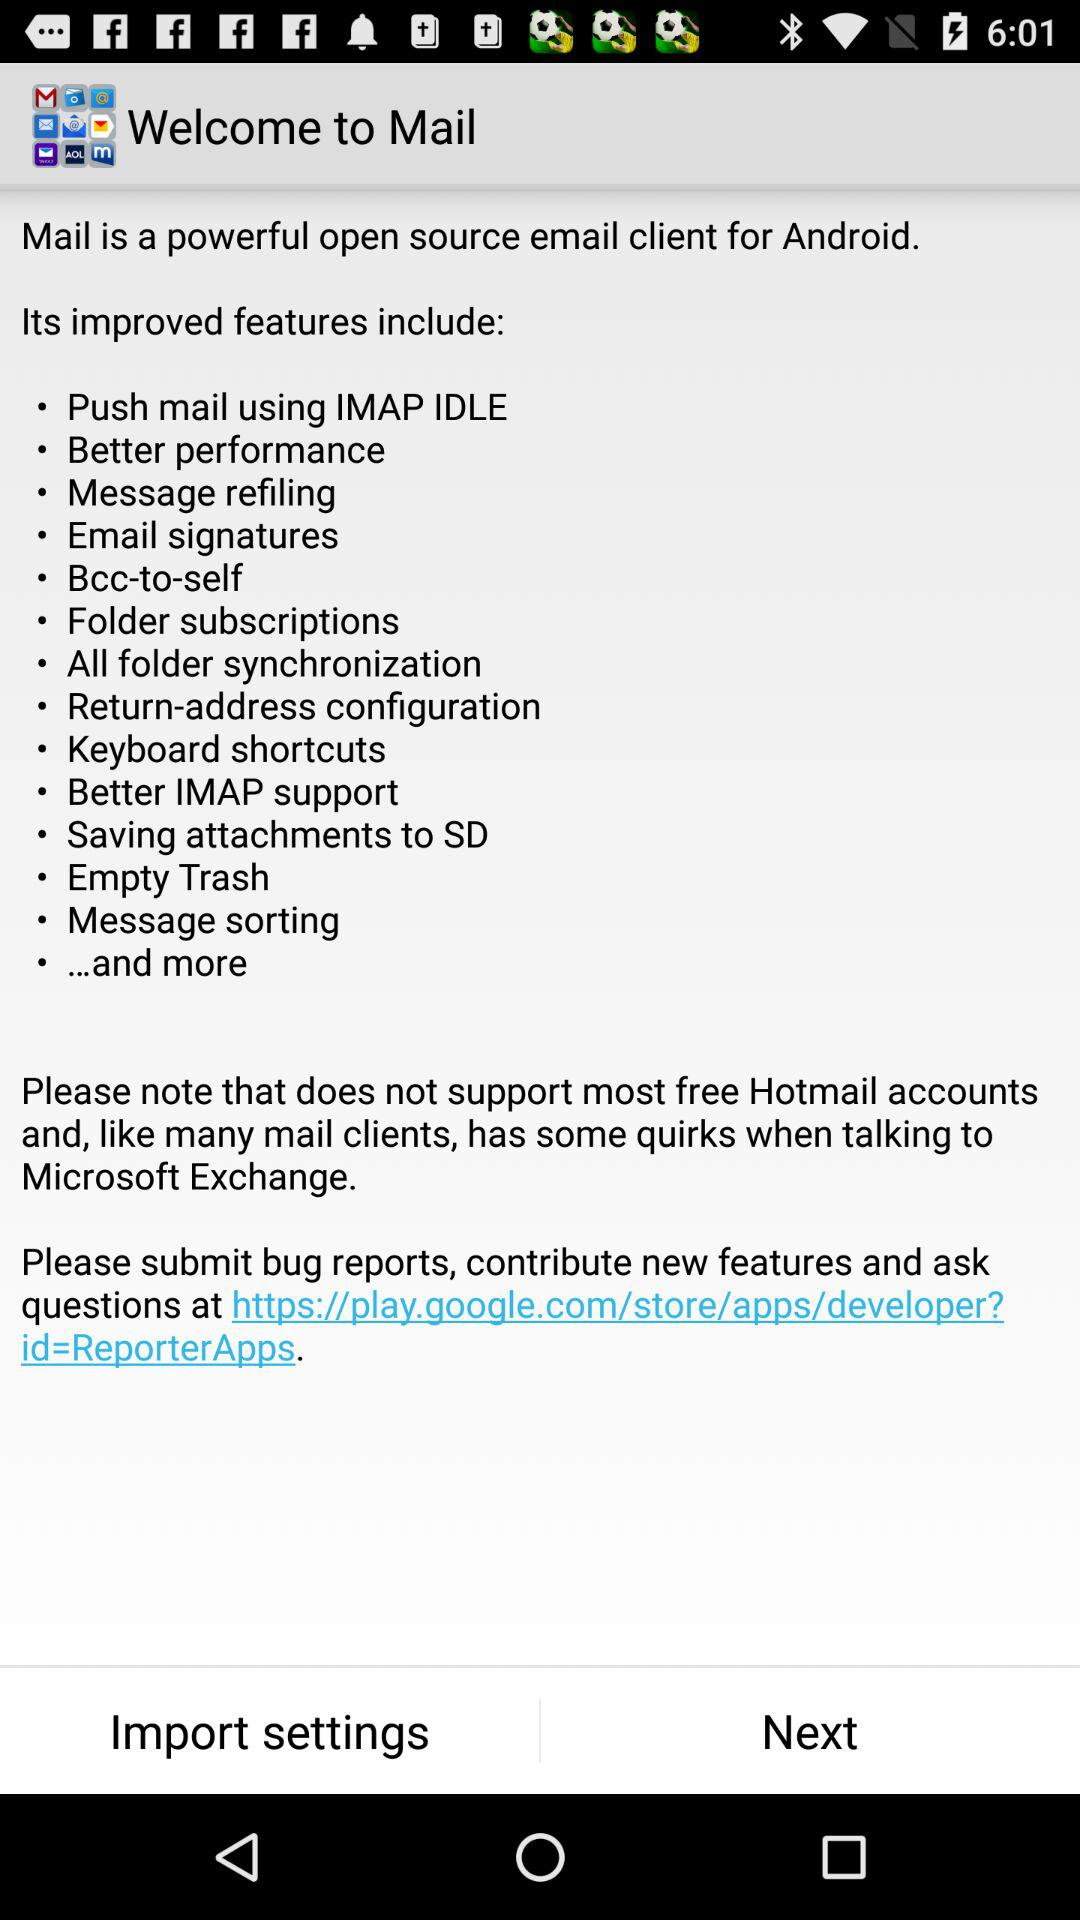What is the given URL address? The given URL address is https://play.google.com/store/apps/developer?id=ReporterApps. 